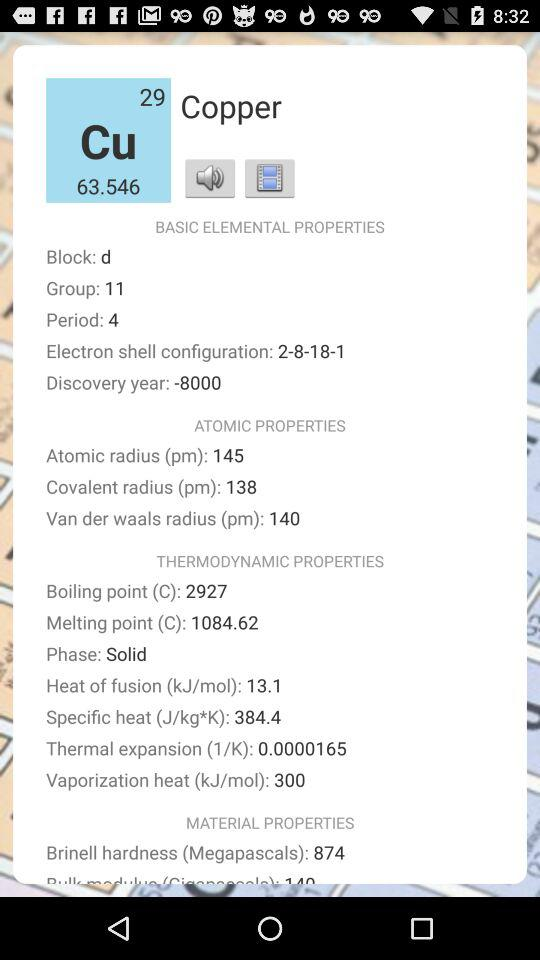In which group is copper present? The copper is present in group 11. 